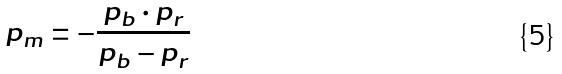<formula> <loc_0><loc_0><loc_500><loc_500>p _ { m } = - \frac { p _ { b } \cdot p _ { r } } { p _ { b } - p _ { r } }</formula> 